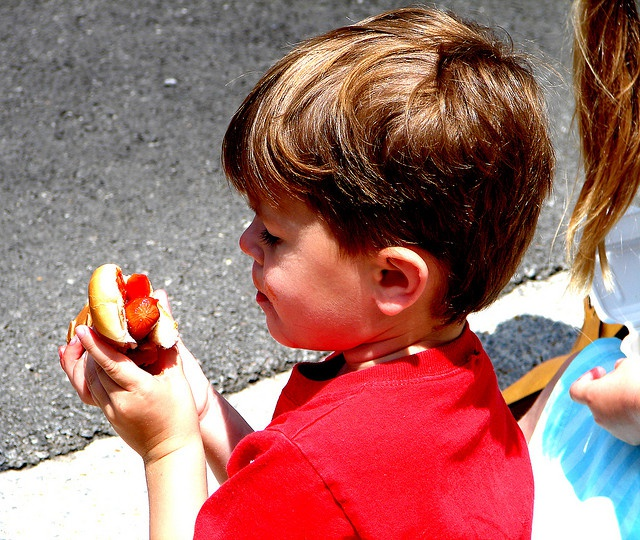Describe the objects in this image and their specific colors. I can see people in gray, red, black, and maroon tones, people in gray, white, maroon, and lightblue tones, and hot dog in gray, ivory, red, and maroon tones in this image. 